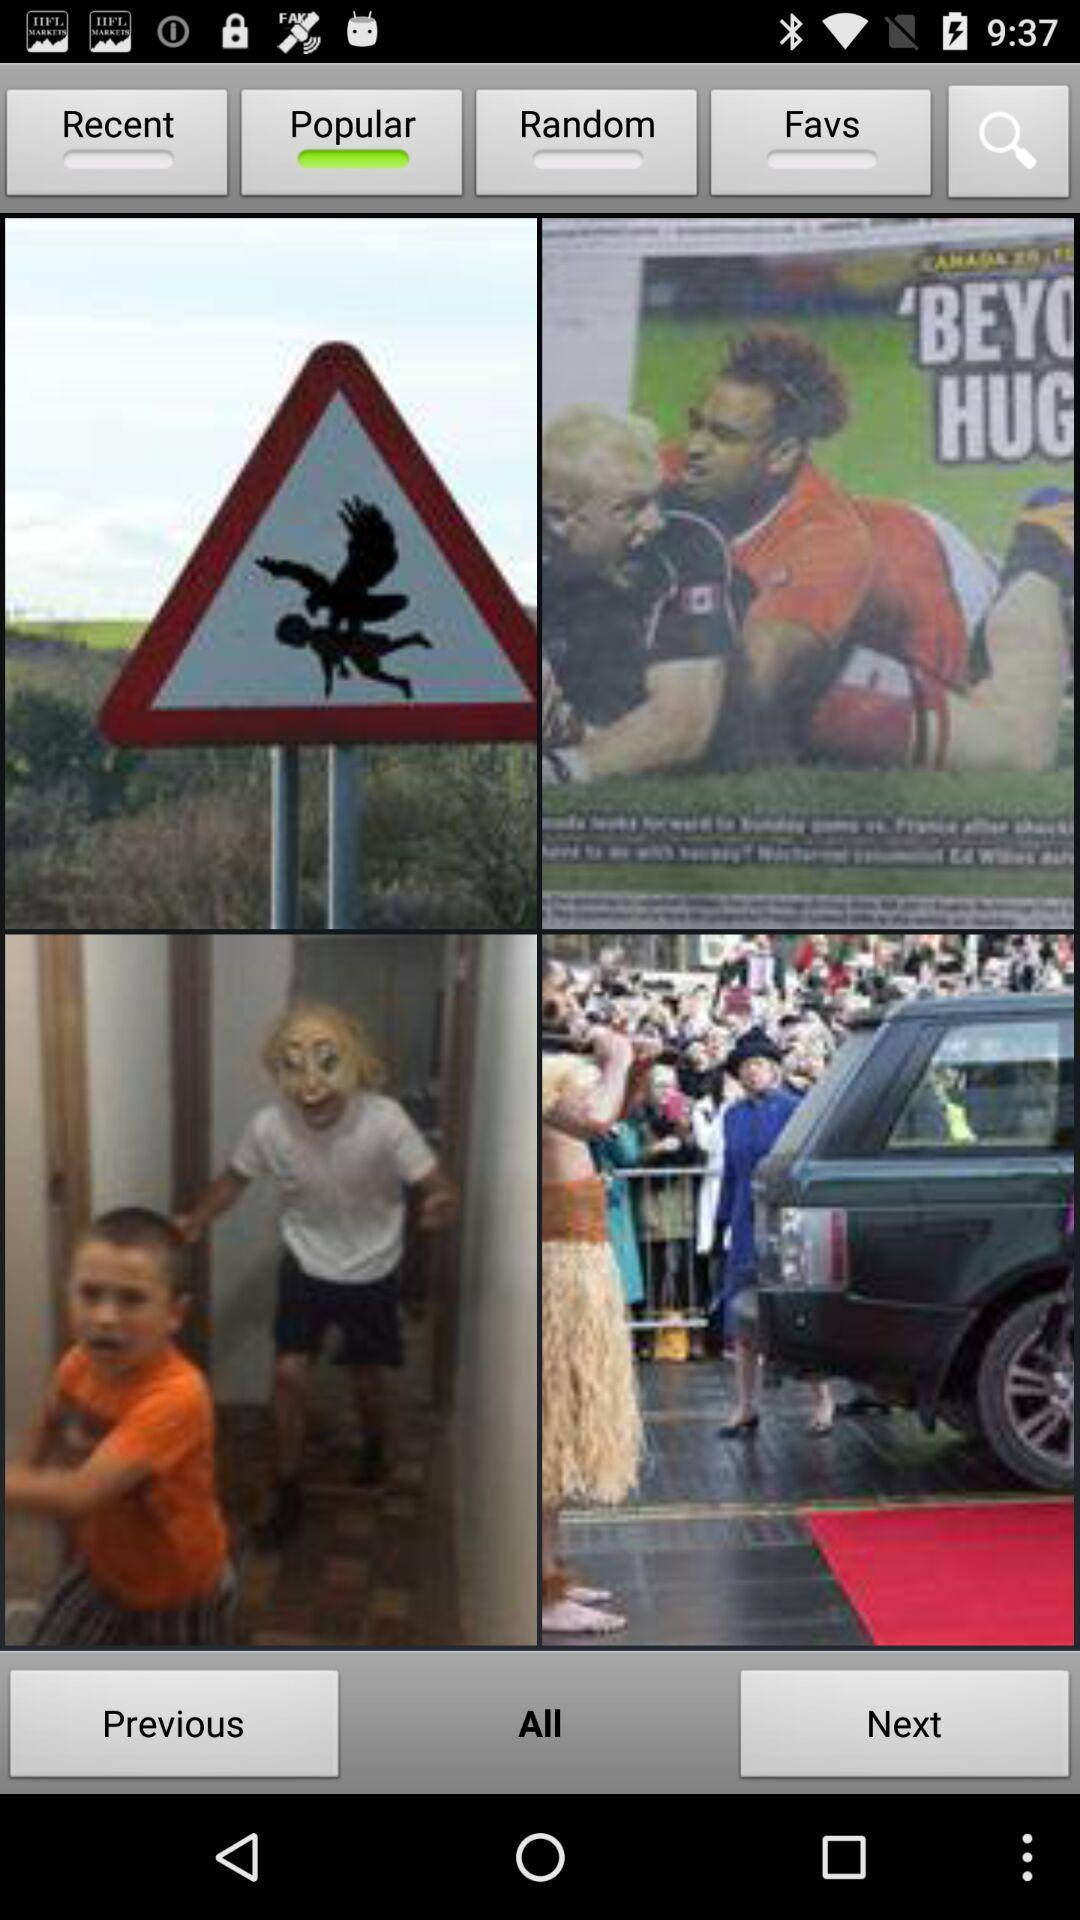Which tab is selected? The selected tab is "Popular". 